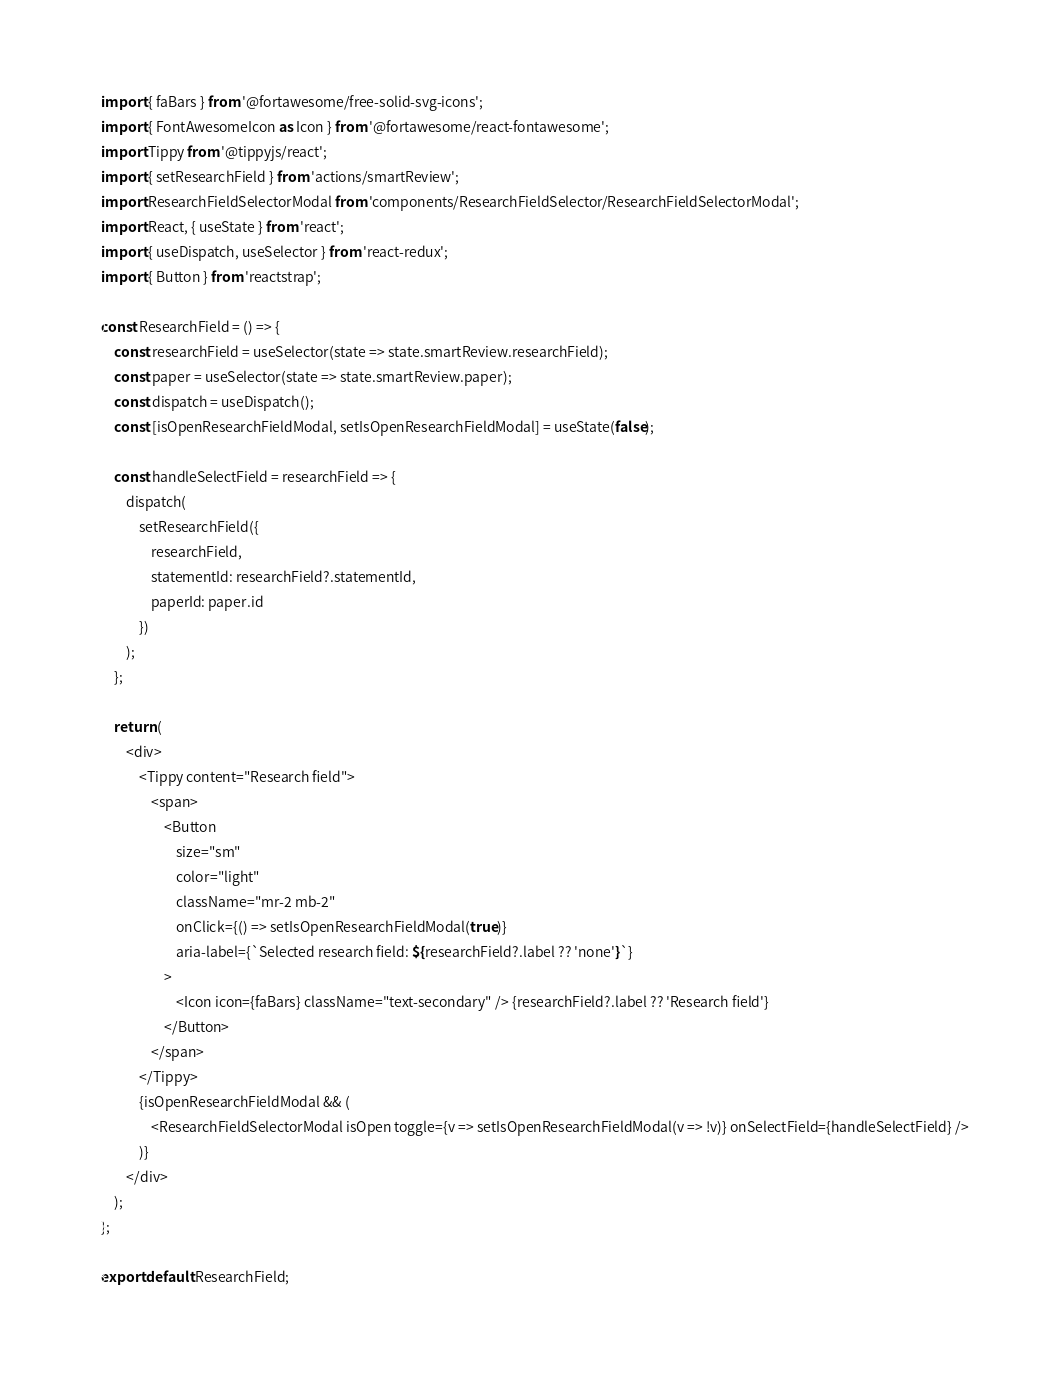<code> <loc_0><loc_0><loc_500><loc_500><_JavaScript_>import { faBars } from '@fortawesome/free-solid-svg-icons';
import { FontAwesomeIcon as Icon } from '@fortawesome/react-fontawesome';
import Tippy from '@tippyjs/react';
import { setResearchField } from 'actions/smartReview';
import ResearchFieldSelectorModal from 'components/ResearchFieldSelector/ResearchFieldSelectorModal';
import React, { useState } from 'react';
import { useDispatch, useSelector } from 'react-redux';
import { Button } from 'reactstrap';

const ResearchField = () => {
    const researchField = useSelector(state => state.smartReview.researchField);
    const paper = useSelector(state => state.smartReview.paper);
    const dispatch = useDispatch();
    const [isOpenResearchFieldModal, setIsOpenResearchFieldModal] = useState(false);

    const handleSelectField = researchField => {
        dispatch(
            setResearchField({
                researchField,
                statementId: researchField?.statementId,
                paperId: paper.id
            })
        );
    };

    return (
        <div>
            <Tippy content="Research field">
                <span>
                    <Button
                        size="sm"
                        color="light"
                        className="mr-2 mb-2"
                        onClick={() => setIsOpenResearchFieldModal(true)}
                        aria-label={`Selected research field: ${researchField?.label ?? 'none'}`}
                    >
                        <Icon icon={faBars} className="text-secondary" /> {researchField?.label ?? 'Research field'}
                    </Button>
                </span>
            </Tippy>
            {isOpenResearchFieldModal && (
                <ResearchFieldSelectorModal isOpen toggle={v => setIsOpenResearchFieldModal(v => !v)} onSelectField={handleSelectField} />
            )}
        </div>
    );
};

export default ResearchField;
</code> 